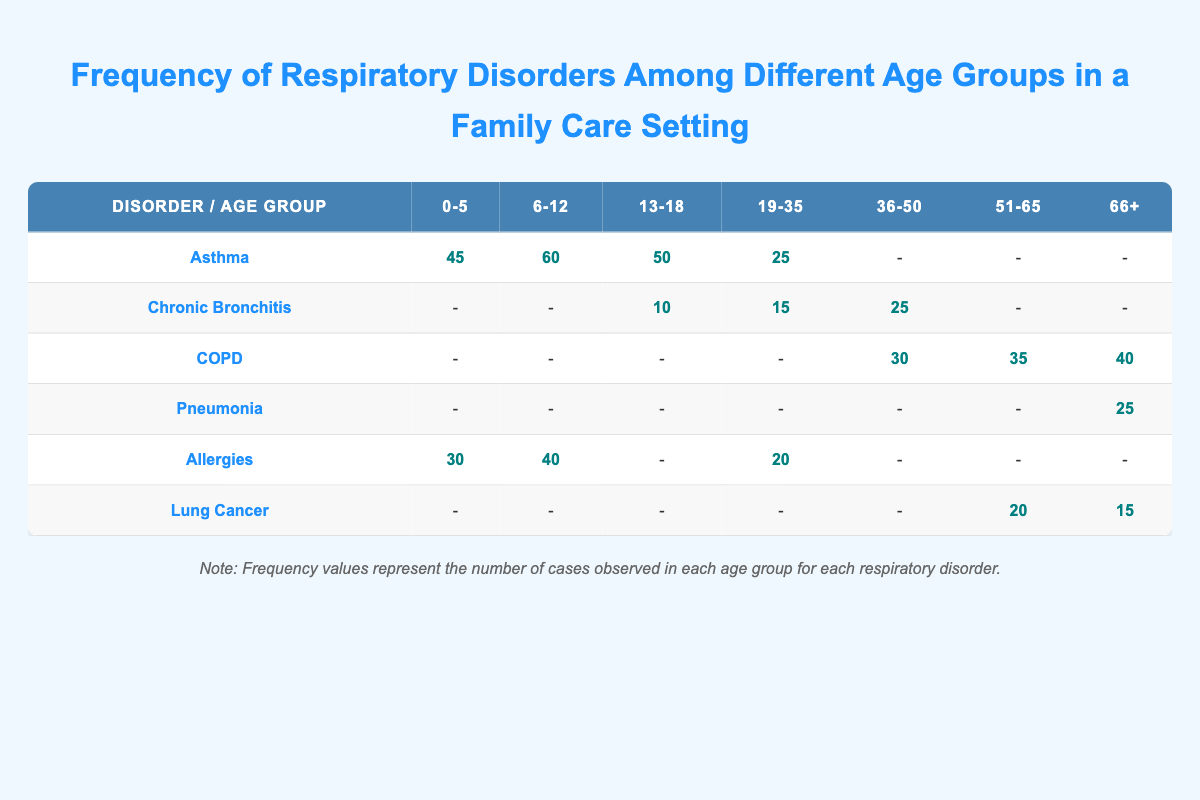What is the frequency of asthma in the age group 6-12? The frequency of asthma in the age group 6-12 is directly provided in the table under the corresponding row and column. It shows a value of 60.
Answer: 60 Which age group has the highest frequency of allergies? By scanning the "Allergies" row, we can identify the frequencies for each age group. The highest frequency is found in the age group 6-12, which shows a value of 40.
Answer: 40 Is there any occurrence of Chronic Bronchitis in the age group 0-5? The table shows a hyphen in the "Chronic Bronchitis" row under the age group 0-5, indicating that there are no cases reported in this age group.
Answer: No How many total cases of COPD are there across the age groups 36-50, 51-65, and 66+? We look at the "COPD" row for the specified age groups. The frequencies are 30 (36-50), 35 (51-65), and 40 (66+). Summing these values gives: 30 + 35 + 40 = 105.
Answer: 105 What is the average frequency of respiratory disorders for the age group 19-35? The relevant disorders for the age group 19-35 are Asthma (25), Allergies (20), and Chronic Bronchitis (15). We'll sum these frequencies: 25 + 20 + 15 = 60 and divide by the number of disorders (3) to find the average: 60 / 3 = 20.
Answer: 20 In which age group is Pneumonia most frequently observed? The only occurrence of Pneumonia is found in the age group 66+, which shows a frequency of 25. This makes it the age group with the sole presence of this disorder in the table.
Answer: 66+ Is the frequency of Lung Cancer higher in the 51-65 age group compared to the 66+ age group? We check the frequencies for Lung Cancer: 51-65 shows 20 cases while 66+ shows 15 cases. Since 20 is greater than 15, we conclude that the frequency is higher in the 51-65 age group.
Answer: Yes What is the total frequency of Asthma and Allergies in the age group 0-5? The frequency of Asthma in the age group 0-5 is 45, and for Allergies, it is 30. Adding these values together gives: 45 + 30 = 75.
Answer: 75 Which respiratory disorder shows an increasing frequency with age, according to the table? By analyzing the occurrences of COPD, we see frequencies of 30 (36-50), 35 (51-65), and 40 (66+). This trend indicates a consistent increase in frequency with age.
Answer: COPD 